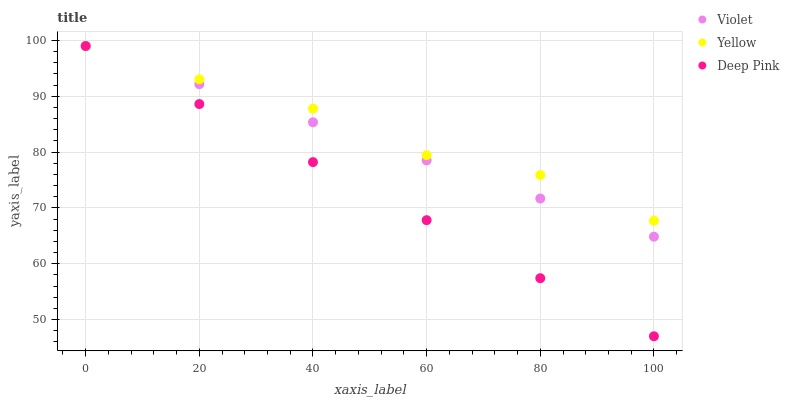Does Deep Pink have the minimum area under the curve?
Answer yes or no. Yes. Does Yellow have the maximum area under the curve?
Answer yes or no. Yes. Does Violet have the minimum area under the curve?
Answer yes or no. No. Does Violet have the maximum area under the curve?
Answer yes or no. No. Is Violet the smoothest?
Answer yes or no. Yes. Is Yellow the roughest?
Answer yes or no. Yes. Is Yellow the smoothest?
Answer yes or no. No. Is Violet the roughest?
Answer yes or no. No. Does Deep Pink have the lowest value?
Answer yes or no. Yes. Does Violet have the lowest value?
Answer yes or no. No. Does Violet have the highest value?
Answer yes or no. Yes. Does Deep Pink intersect Yellow?
Answer yes or no. Yes. Is Deep Pink less than Yellow?
Answer yes or no. No. Is Deep Pink greater than Yellow?
Answer yes or no. No. 